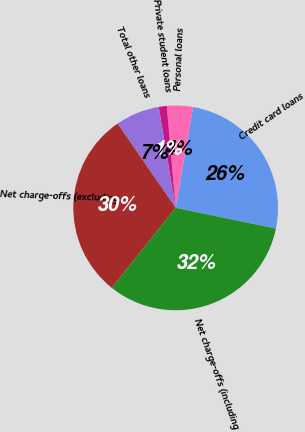Convert chart. <chart><loc_0><loc_0><loc_500><loc_500><pie_chart><fcel>Credit card loans<fcel>Personal loans<fcel>Private student loans<fcel>Total other loans<fcel>Net charge-offs (excluding<fcel>Net charge-offs (including<nl><fcel>25.51%<fcel>4.11%<fcel>1.27%<fcel>6.95%<fcel>29.66%<fcel>32.49%<nl></chart> 